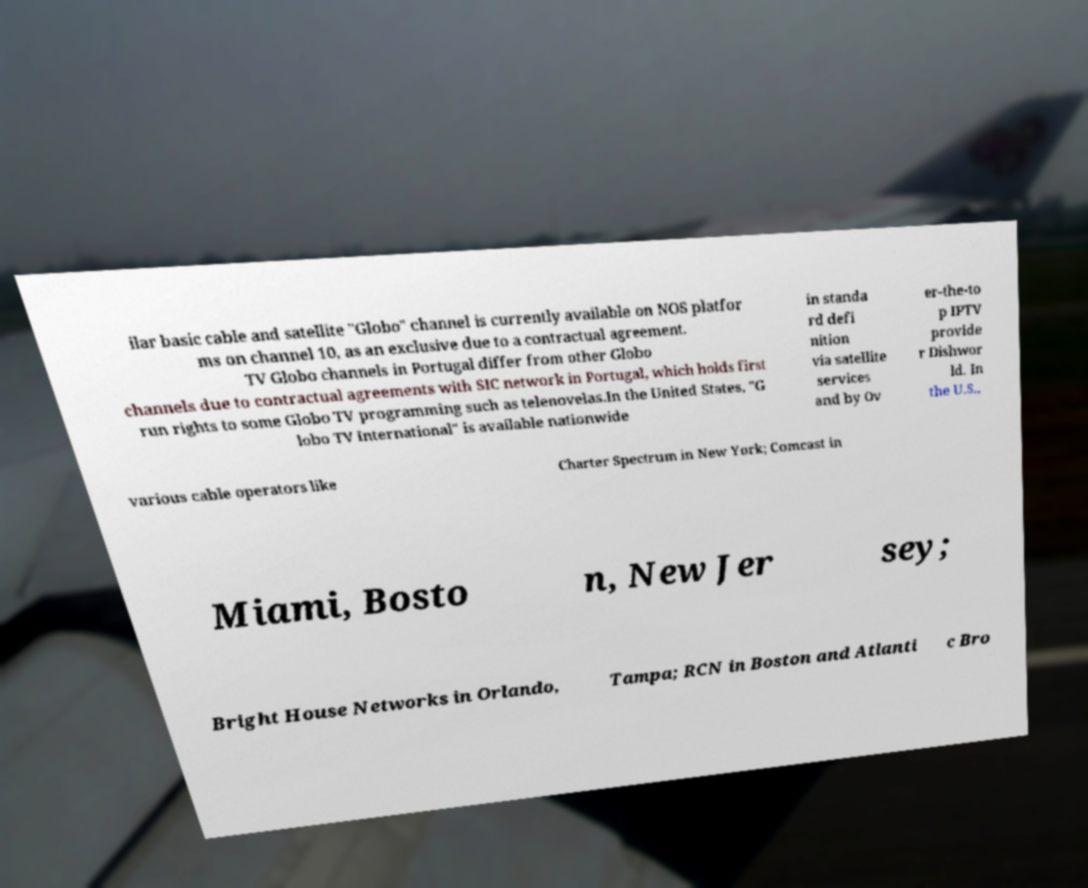There's text embedded in this image that I need extracted. Can you transcribe it verbatim? ilar basic cable and satellite "Globo" channel is currently available on NOS platfor ms on channel 10, as an exclusive due to a contractual agreement. TV Globo channels in Portugal differ from other Globo channels due to contractual agreements with SIC network in Portugal, which holds first run rights to some Globo TV programming such as telenovelas.In the United States, "G lobo TV International" is available nationwide in standa rd defi nition via satellite services and by Ov er-the-to p IPTV provide r Dishwor ld. In the U.S., various cable operators like Charter Spectrum in New York; Comcast in Miami, Bosto n, New Jer sey; Bright House Networks in Orlando, Tampa; RCN in Boston and Atlanti c Bro 